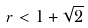<formula> <loc_0><loc_0><loc_500><loc_500>r < 1 + \sqrt { 2 }</formula> 